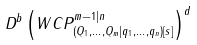Convert formula to latex. <formula><loc_0><loc_0><loc_500><loc_500>D ^ { b } \left ( W C P ^ { m - 1 | n } _ { ( Q _ { 1 } , \dots , Q _ { m } | q _ { 1 } , \dots , q _ { n } ) [ s ] } \right ) ^ { d }</formula> 